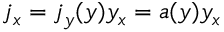Convert formula to latex. <formula><loc_0><loc_0><loc_500><loc_500>j _ { x } = j _ { y } ( y ) y _ { x } = a ( y ) y _ { x }</formula> 